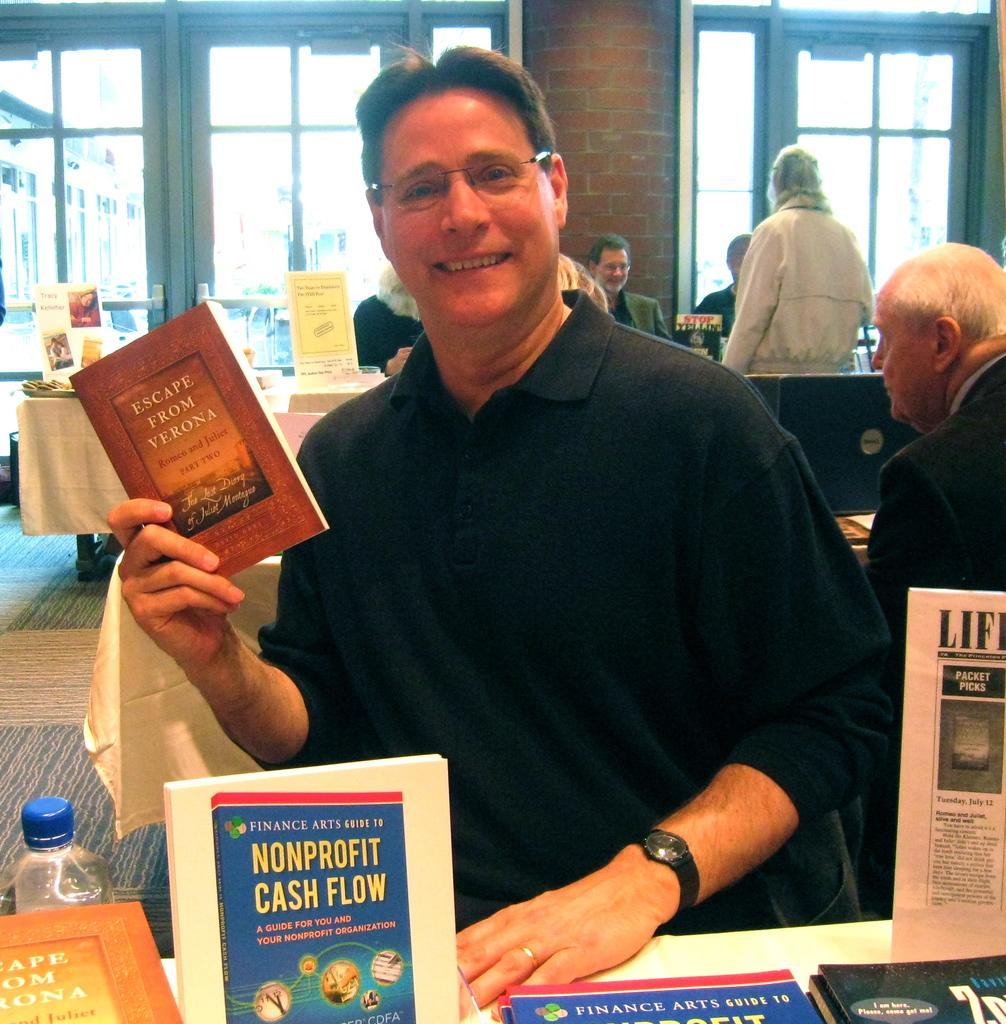<image>
Relay a brief, clear account of the picture shown. A man is holding a book titled Escape From Verona. 